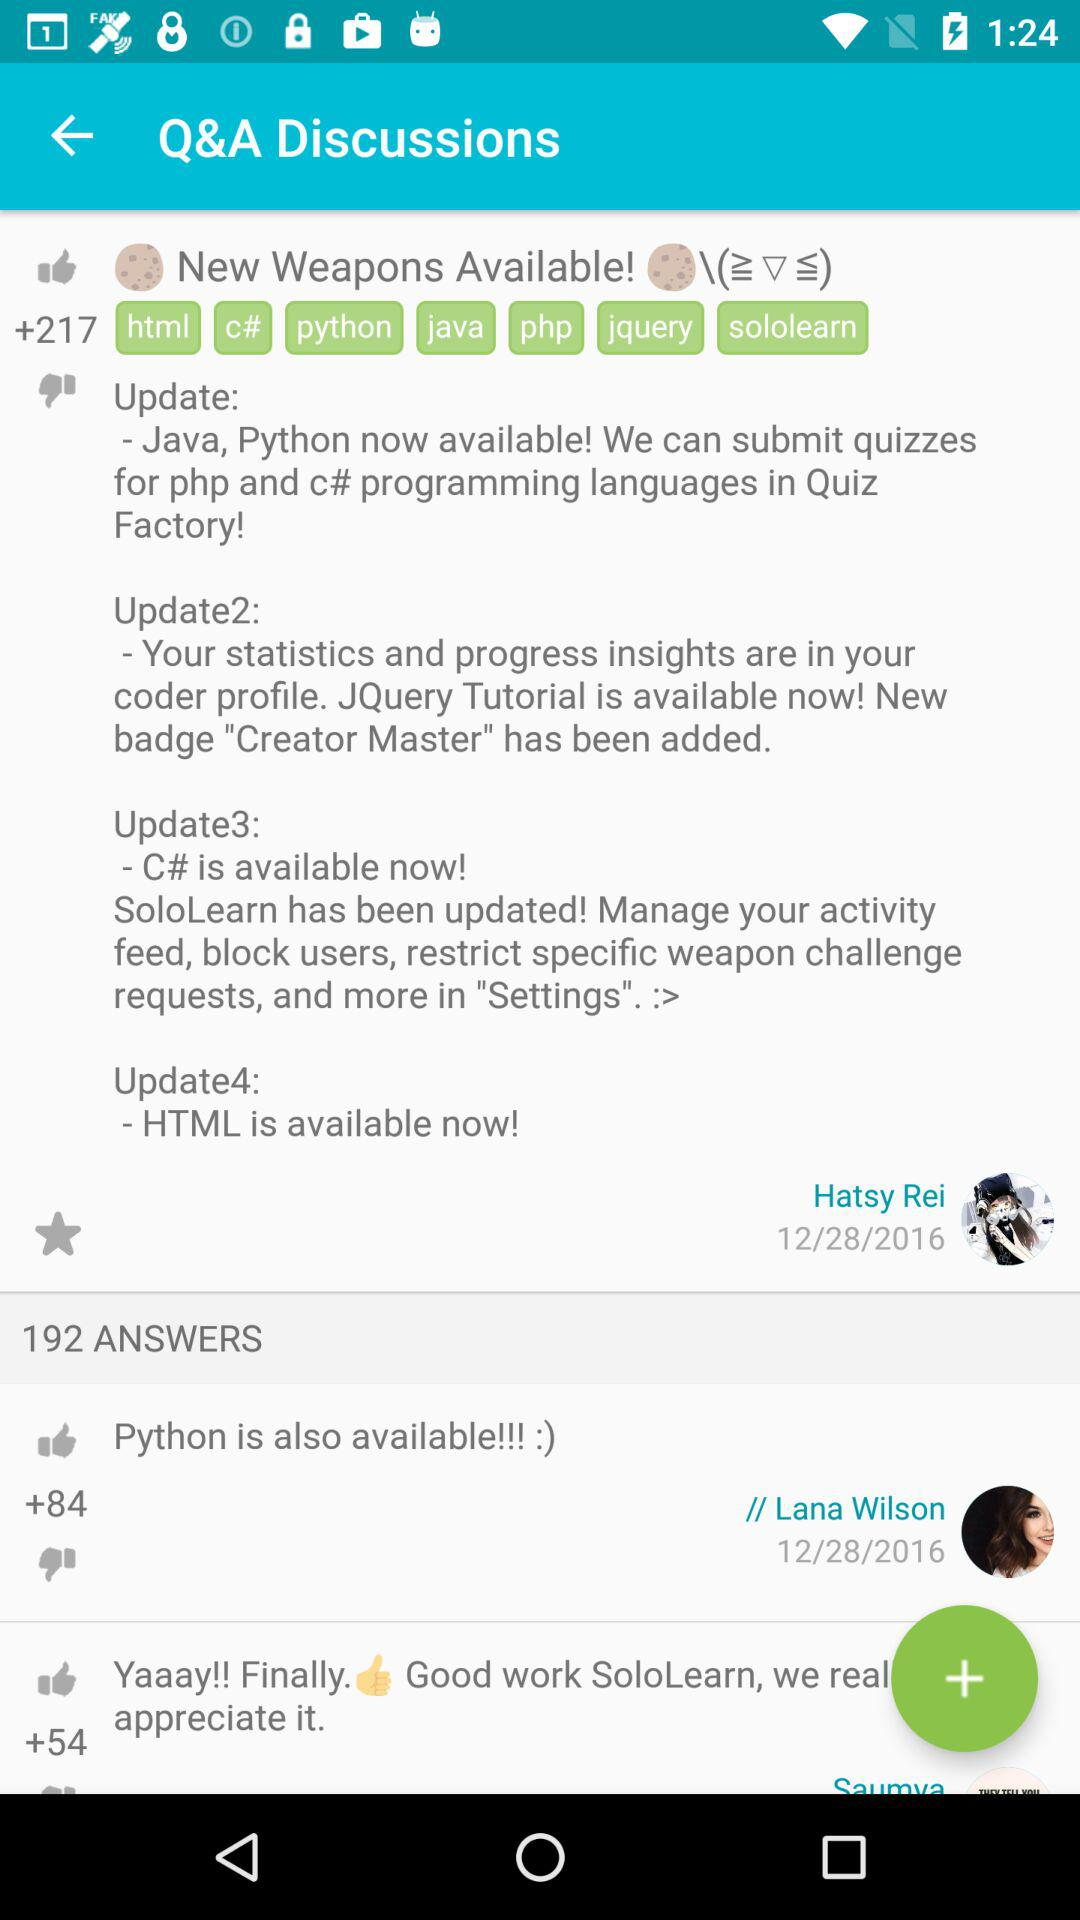What is the number of answers? The number of answers is 192. 